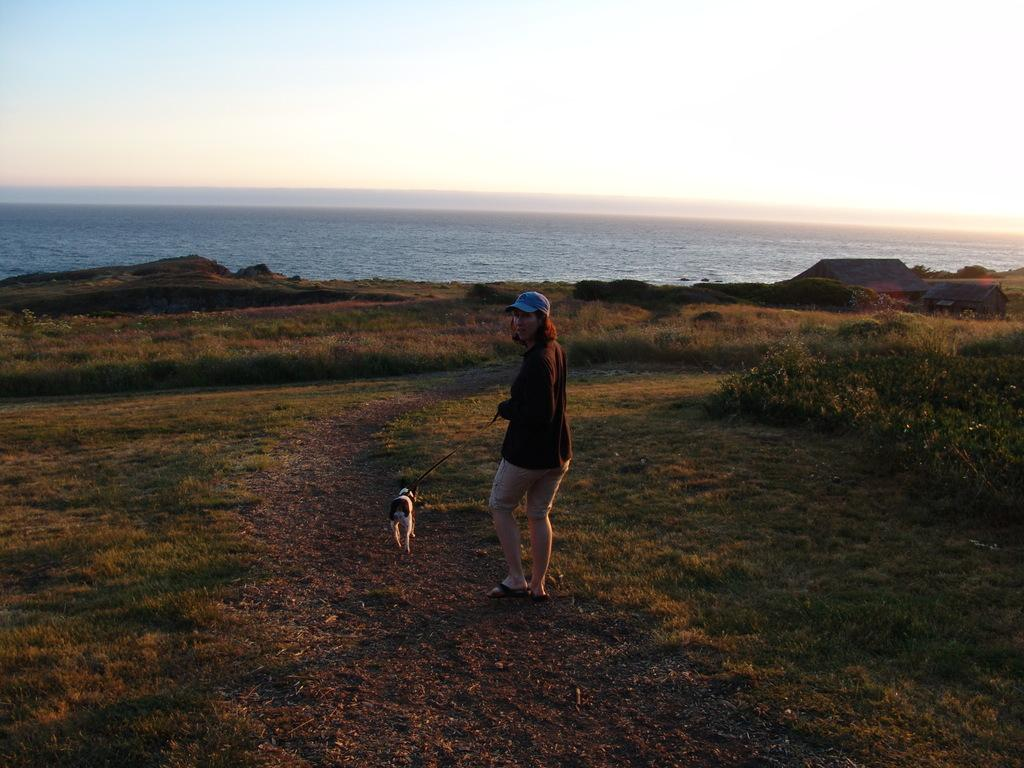What type of vegetation is present in the image? There is grass in the image. Who or what else can be seen in the image? There is a person and a dog in the image. What can be seen in the background of the image? Water and the sky are visible in the background of the image. Where is the mailbox located in the image? There is no mailbox present in the image. What type of writing can be seen on the dog's collar in the image? There is no writing visible on the dog's collar in the image, as the dog is not wearing a collar. 